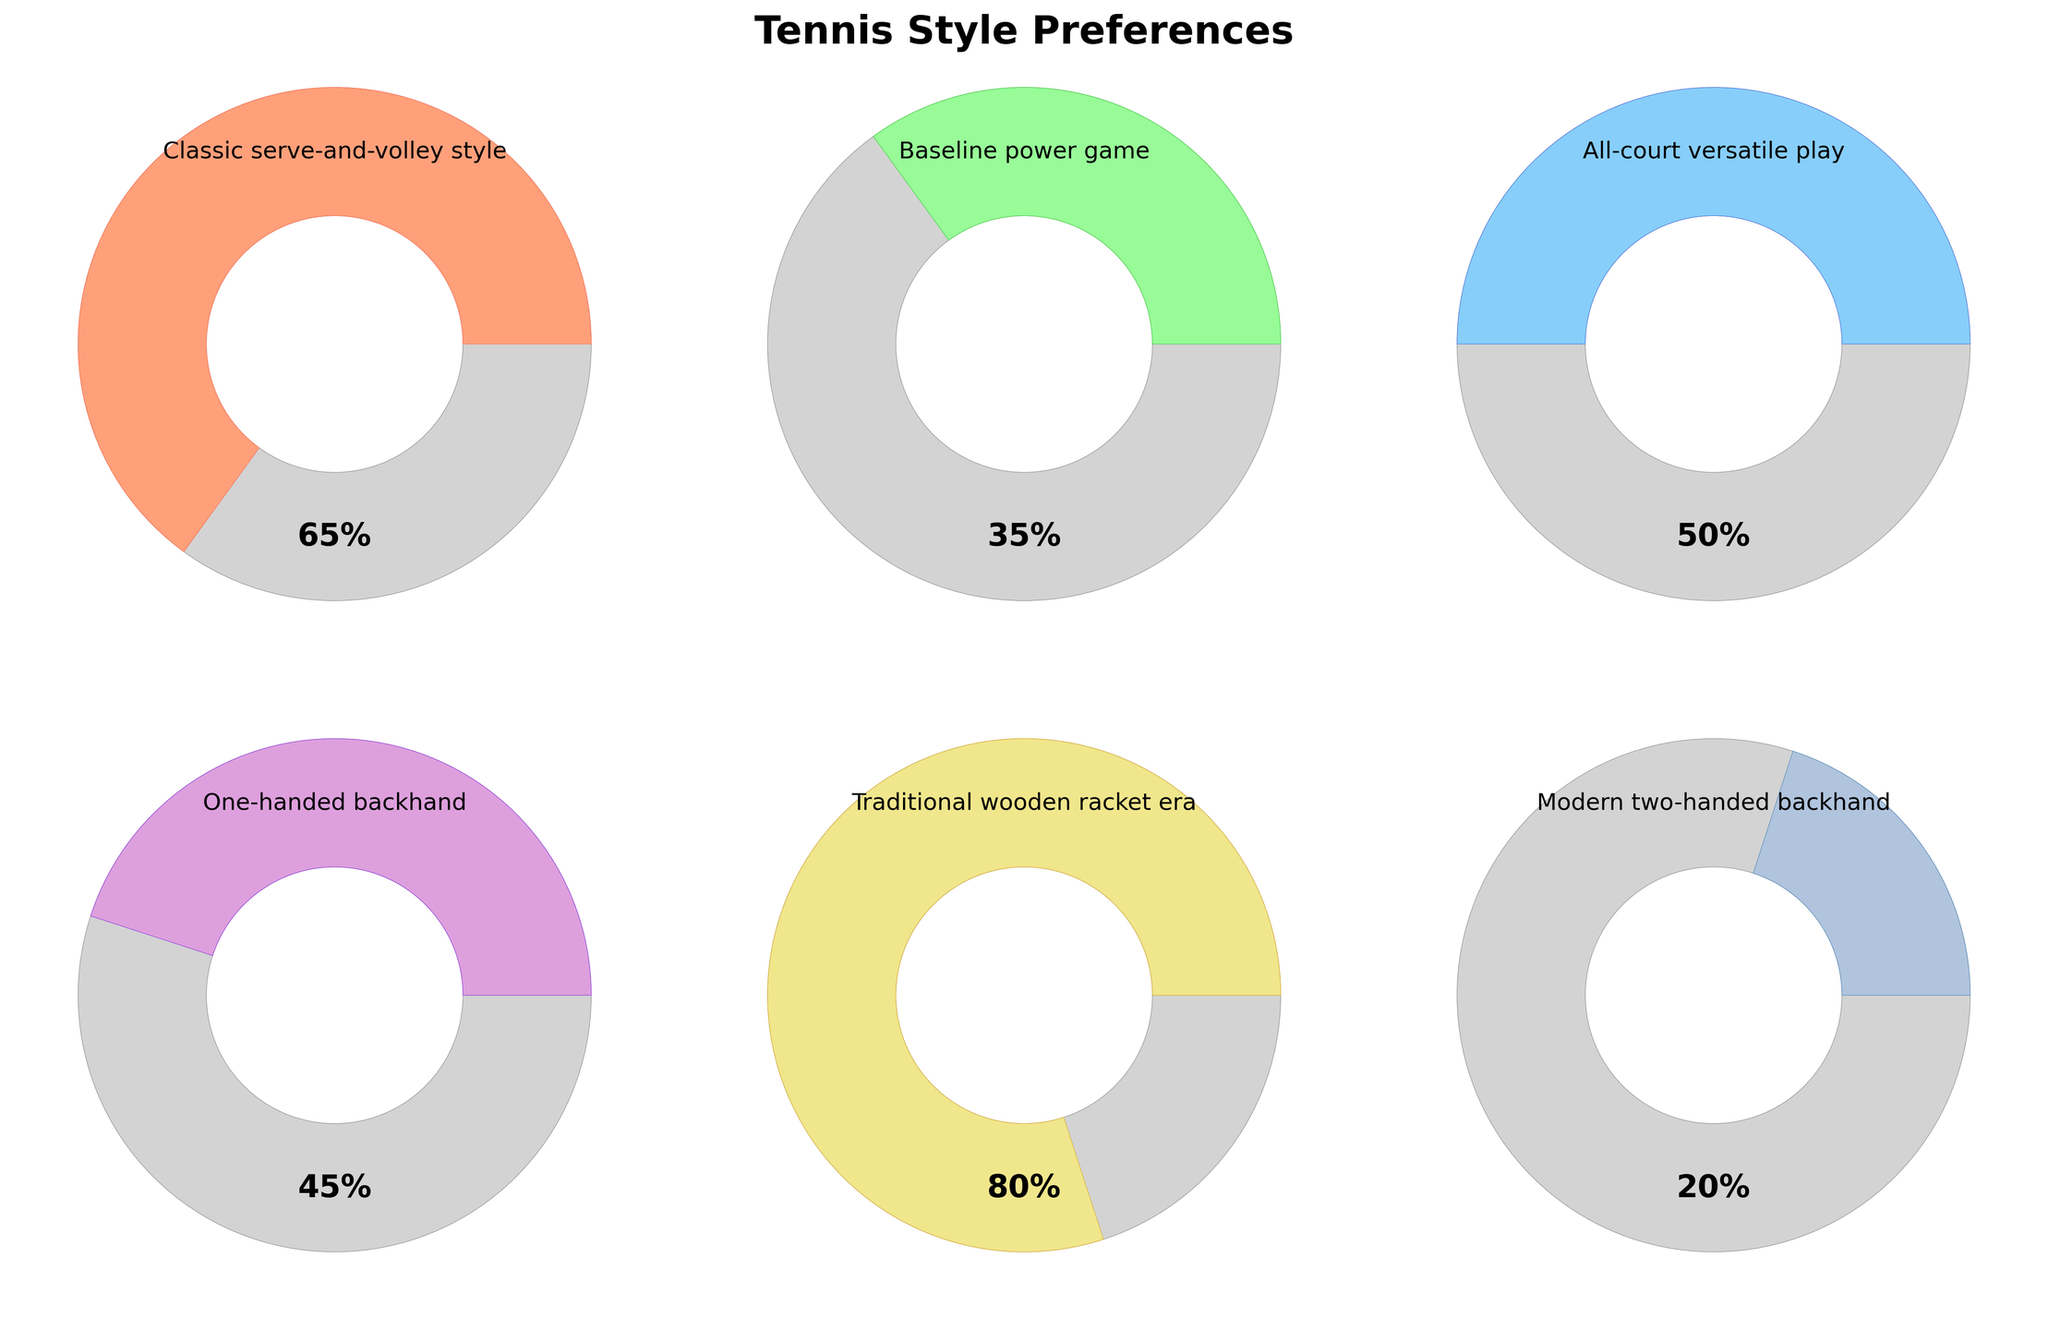What's the title of the figure? The title of the figure is prominently placed at the top and reads "Tennis Style Preferences".
Answer: Tennis Style Preferences Which tennis playing style has the highest preference percentage? By looking at the gauge charts, the segment labeled "Traditional wooden racket era" shows the highest percentage of 80%.
Answer: Traditional wooden racket era How many tennis playing styles are displayed in the figure? The figure contains six different gauge charts, each representing a different tennis playing style preference.
Answer: Six Which two playing styles have an equal preference percentage? From the gauge charts, "Baseline power game" and "Modern two-handed backhand" both have the same preference percentage of 20%.
Answer: Modern two-handed backhand and Baseline power game What is the combined preference percentage of the "Classic serve-and-volley style" and the "All-court versatile play"? The "Classic serve-and-volley style" has a preference of 65% and the "All-court versatile play" has 50%. Adding these together gives 115%.
Answer: 115% Which playing style has a higher preference, "One-handed backhand" or "Baseline power game"? The gauge chart for "One-handed backhand" shows 45%, whereas the "Baseline power game" shows only 35%. Therefore, "One-handed backhand" has a higher preference.
Answer: One-handed backhand What is the average preference percentage across all displayed playing styles? To find the average: (65% + 35% + 50% + 45% + 80% + 20%) / 6 = 295% / 6 ≈ 49.17%.
Answer: 49.17% By how much does the preference for the "Traditional wooden racket era" exceed the "Classic serve-and-volley style"? The "Traditional wooden racket era" has 80% and the "Classic serve-and-volley style" has 65%. The difference is 80% - 65% = 15%.
Answer: 15% Is there any playing style with a lower preference than the "One-handed backhand"? Yes, the "Baseline power game" at 35% and the "Modern two-handed backhand" at 20% both have lower preferences than "One-handed backhand" at 45%.
Answer: Yes 